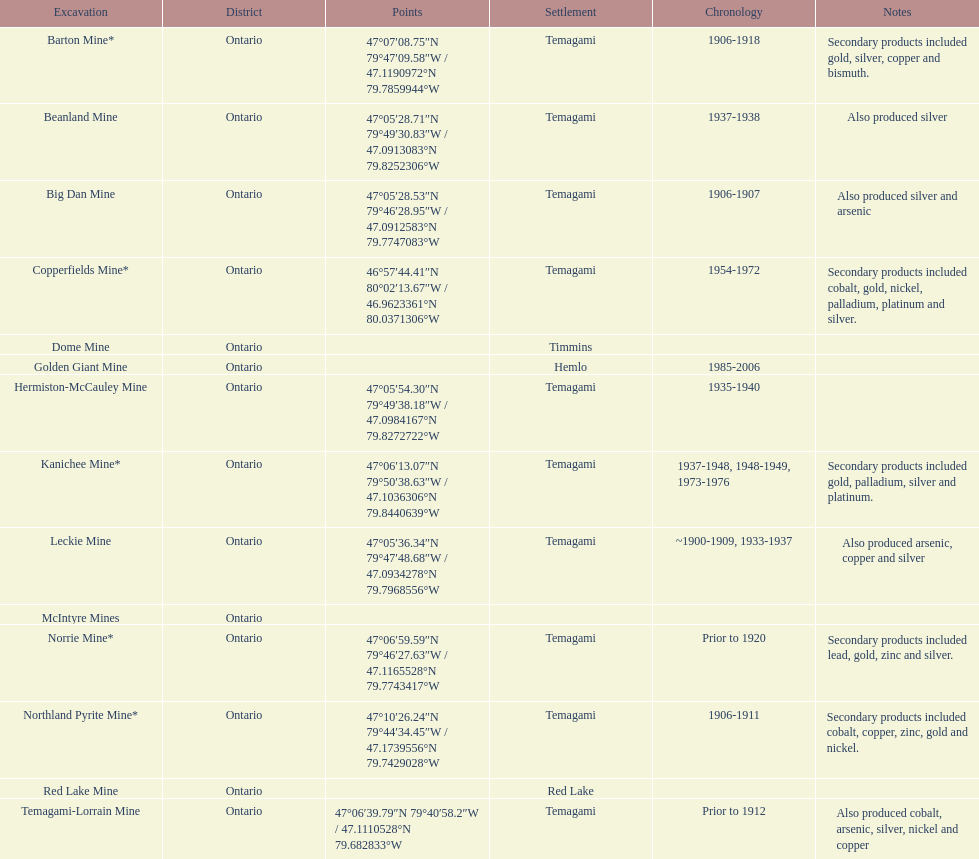What mine is in the town of timmins? Dome Mine. 